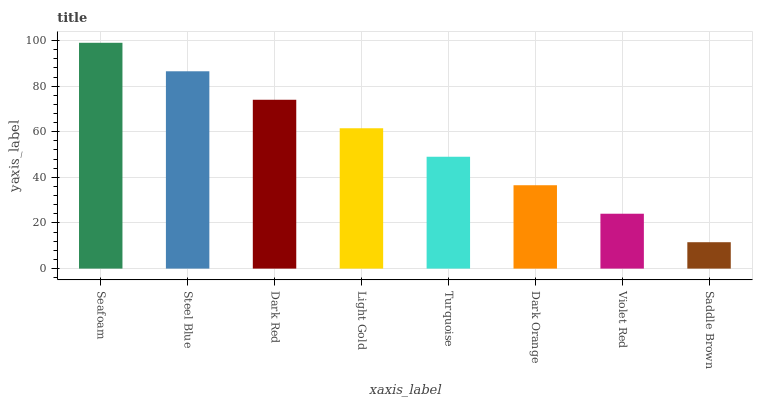Is Saddle Brown the minimum?
Answer yes or no. Yes. Is Seafoam the maximum?
Answer yes or no. Yes. Is Steel Blue the minimum?
Answer yes or no. No. Is Steel Blue the maximum?
Answer yes or no. No. Is Seafoam greater than Steel Blue?
Answer yes or no. Yes. Is Steel Blue less than Seafoam?
Answer yes or no. Yes. Is Steel Blue greater than Seafoam?
Answer yes or no. No. Is Seafoam less than Steel Blue?
Answer yes or no. No. Is Light Gold the high median?
Answer yes or no. Yes. Is Turquoise the low median?
Answer yes or no. Yes. Is Steel Blue the high median?
Answer yes or no. No. Is Light Gold the low median?
Answer yes or no. No. 